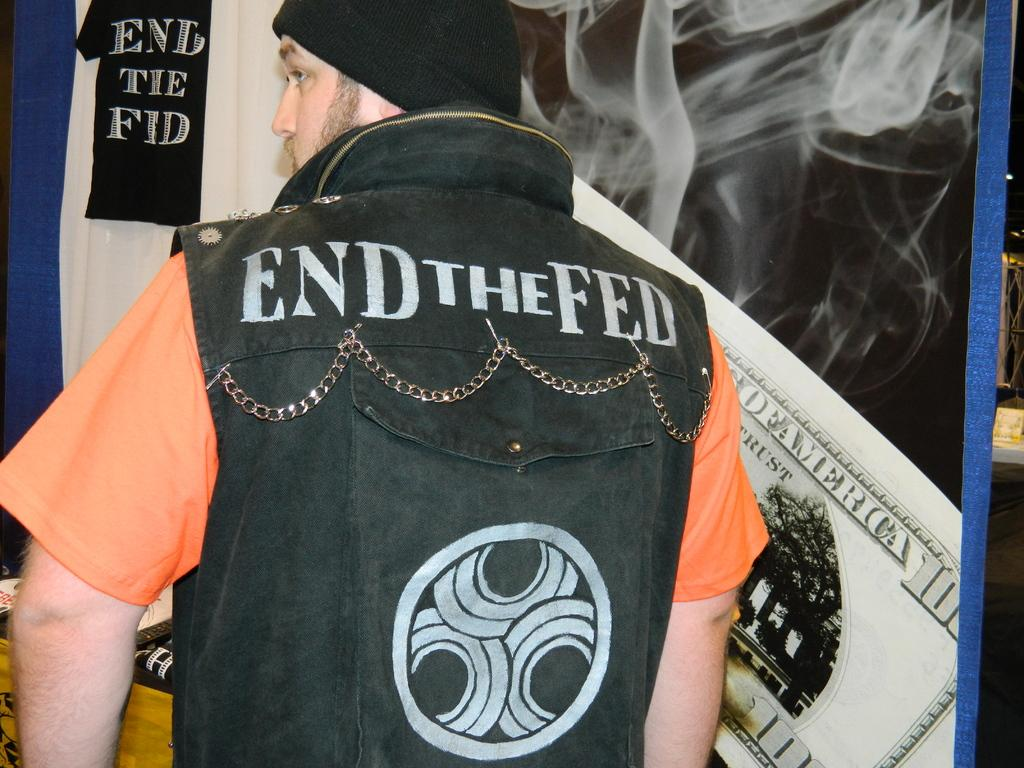Provide a one-sentence caption for the provided image. A man wears an End the Fed vest over an orange T shirt. 